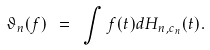Convert formula to latex. <formula><loc_0><loc_0><loc_500><loc_500>\vartheta _ { n } ( f ) \ = \ \int f ( t ) d H _ { n , c _ { n } } ( t ) .</formula> 